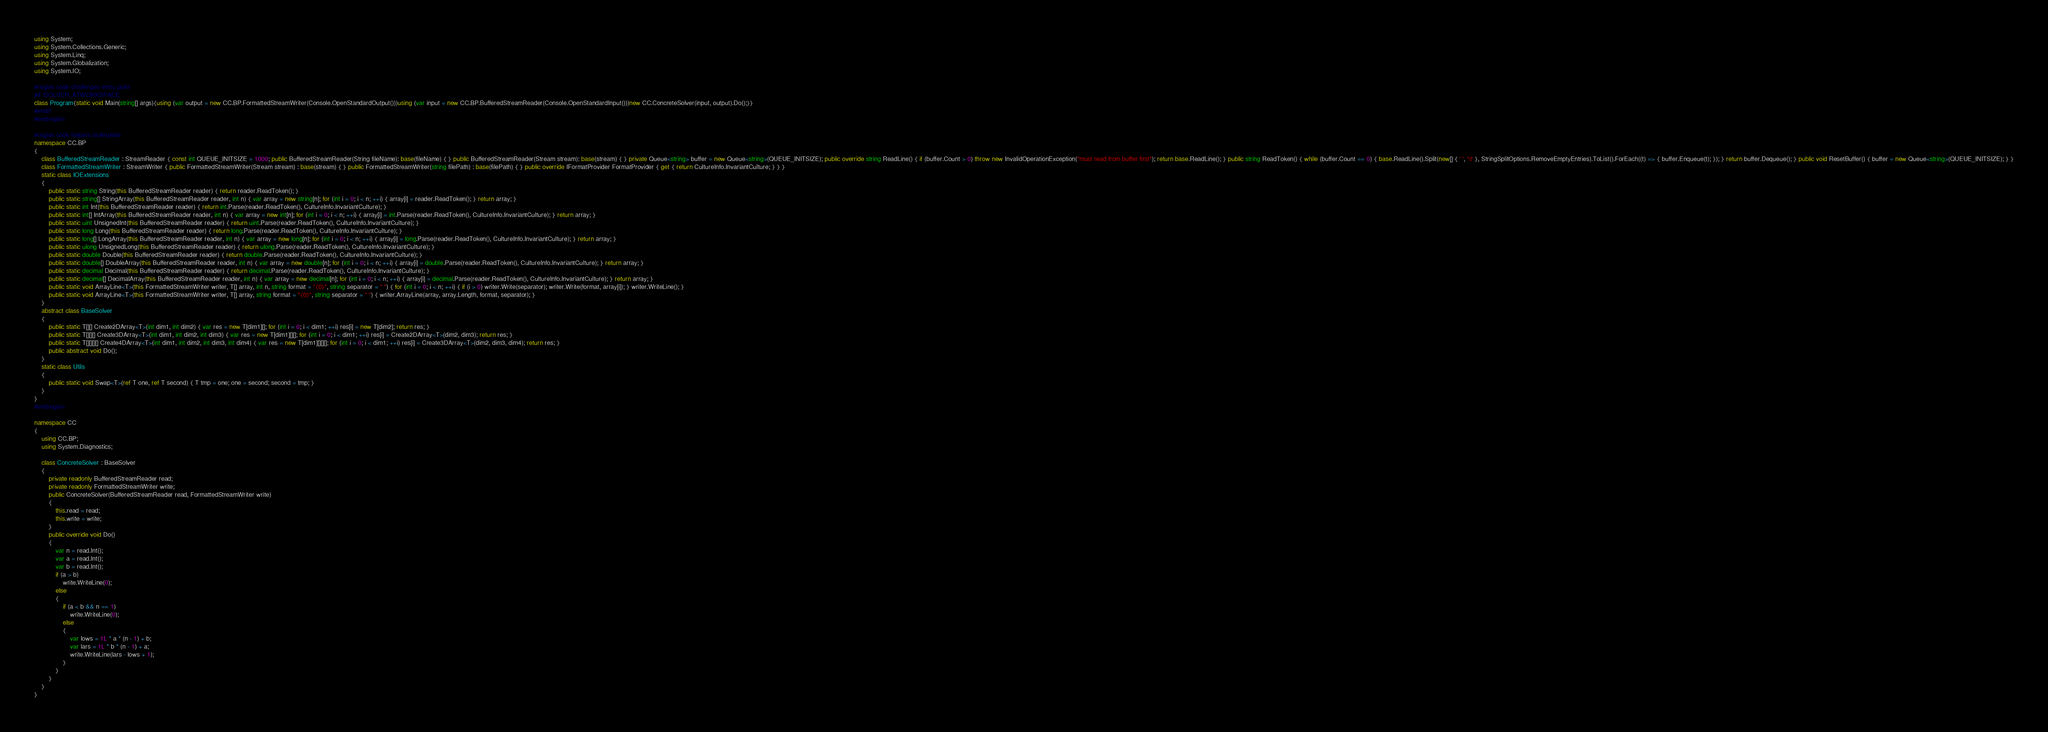Convert code to text. <code><loc_0><loc_0><loc_500><loc_500><_C#_>using System;
using System.Collections.Generic;
using System.Linq;
using System.Globalization;
using System.IO;

#region code challenges entry point
#if !SOLVER_ATWORKSPACE
class Program{static void Main(string[] args){using (var output = new CC.BP.FormattedStreamWriter(Console.OpenStandardOutput()))using (var input = new CC.BP.BufferedStreamReader(Console.OpenStandardInput()))new CC.ConcreteSolver(input, output).Do();}}
#endif
#endregion

#region code helpers boilerplate
namespace CC.BP
{    
    class BufferedStreamReader : StreamReader { const int QUEUE_INITSIZE = 1000; public BufferedStreamReader(String fileName): base(fileName) { } public BufferedStreamReader(Stream stream): base(stream) { } private Queue<string> buffer = new Queue<string>(QUEUE_INITSIZE); public override string ReadLine() { if (buffer.Count > 0) throw new InvalidOperationException("must read from buffer first"); return base.ReadLine(); } public string ReadToken() { while (buffer.Count == 0) { base.ReadLine().Split(new[] { ' ', '\t' }, StringSplitOptions.RemoveEmptyEntries).ToList().ForEach((t) => { buffer.Enqueue(t); }); } return buffer.Dequeue(); } public void ResetBuffer() { buffer = new Queue<string>(QUEUE_INITSIZE); } }
    class FormattedStreamWriter : StreamWriter { public FormattedStreamWriter(Stream stream) : base(stream) { } public FormattedStreamWriter(string filePath) : base(filePath) { } public override IFormatProvider FormatProvider { get { return CultureInfo.InvariantCulture; } } }
    static class IOExtensions
    {
        public static string String(this BufferedStreamReader reader) { return reader.ReadToken(); }
        public static string[] StringArray(this BufferedStreamReader reader, int n) { var array = new string[n]; for (int i = 0; i < n; ++i) { array[i] = reader.ReadToken(); } return array; }
        public static int Int(this BufferedStreamReader reader) { return int.Parse(reader.ReadToken(), CultureInfo.InvariantCulture); }
        public static int[] IntArray(this BufferedStreamReader reader, int n) { var array = new int[n]; for (int i = 0; i < n; ++i) { array[i] = int.Parse(reader.ReadToken(), CultureInfo.InvariantCulture); } return array; }
        public static uint UnsignedInt(this BufferedStreamReader reader) { return uint.Parse(reader.ReadToken(), CultureInfo.InvariantCulture); }
        public static long Long(this BufferedStreamReader reader) { return long.Parse(reader.ReadToken(), CultureInfo.InvariantCulture); }
        public static long[] LongArray(this BufferedStreamReader reader, int n) { var array = new long[n]; for (int i = 0; i < n; ++i) { array[i] = long.Parse(reader.ReadToken(), CultureInfo.InvariantCulture); } return array; }
        public static ulong UnsignedLong(this BufferedStreamReader reader) { return ulong.Parse(reader.ReadToken(), CultureInfo.InvariantCulture); }
        public static double Double(this BufferedStreamReader reader) { return double.Parse(reader.ReadToken(), CultureInfo.InvariantCulture); }
        public static double[] DoubleArray(this BufferedStreamReader reader, int n) { var array = new double[n]; for (int i = 0; i < n; ++i) { array[i] = double.Parse(reader.ReadToken(), CultureInfo.InvariantCulture); } return array; }
        public static decimal Decimal(this BufferedStreamReader reader) { return decimal.Parse(reader.ReadToken(), CultureInfo.InvariantCulture); }
        public static decimal[] DecimalArray(this BufferedStreamReader reader, int n) { var array = new decimal[n]; for (int i = 0; i < n; ++i) { array[i] = decimal.Parse(reader.ReadToken(), CultureInfo.InvariantCulture); } return array; }
        public static void ArrayLine<T>(this FormattedStreamWriter writer, T[] array, int n, string format = "{0}", string separator = " ") { for (int i = 0; i < n; ++i) { if (i > 0) writer.Write(separator); writer.Write(format, array[i]); } writer.WriteLine(); }
        public static void ArrayLine<T>(this FormattedStreamWriter writer, T[] array, string format = "{0}", string separator = " ") { writer.ArrayLine(array, array.Length, format, separator); }
    }
    abstract class BaseSolver
    {
        public static T[][] Create2DArray<T>(int dim1, int dim2) { var res = new T[dim1][]; for (int i = 0; i < dim1; ++i) res[i] = new T[dim2]; return res; }
        public static T[][][] Create3DArray<T>(int dim1, int dim2, int dim3) { var res = new T[dim1][][]; for (int i = 0; i < dim1; ++i) res[i] = Create2DArray<T>(dim2, dim3); return res; }
        public static T[][][][] Create4DArray<T>(int dim1, int dim2, int dim3, int dim4) { var res = new T[dim1][][][]; for (int i = 0; i < dim1; ++i) res[i] = Create3DArray<T>(dim2, dim3, dim4); return res; }
        public abstract void Do();
    }
    static class Utils
    {
        public static void Swap<T>(ref T one, ref T second) { T tmp = one; one = second; second = tmp; }
    }
}
#endregion

namespace CC
{
    using CC.BP;
    using System.Diagnostics;

    class ConcreteSolver : BaseSolver
    {
        private readonly BufferedStreamReader read;
        private readonly FormattedStreamWriter write;    
        public ConcreteSolver(BufferedStreamReader read, FormattedStreamWriter write)
        {
            this.read = read;
            this.write = write;
        }      
        public override void Do()
        {
            var n = read.Int();
            var a = read.Int();
            var b = read.Int();
            if (a > b)
                write.WriteLine(0);
            else
            {
                if (a < b && n == 1)
                    write.WriteLine(0);
                else
                {
                    var lows = 1L * a * (n - 1) + b;
                    var lars = 1L * b * (n - 1) + a;
                    write.WriteLine(lars - lows + 1);
                }
            }
        }
    }
}</code> 